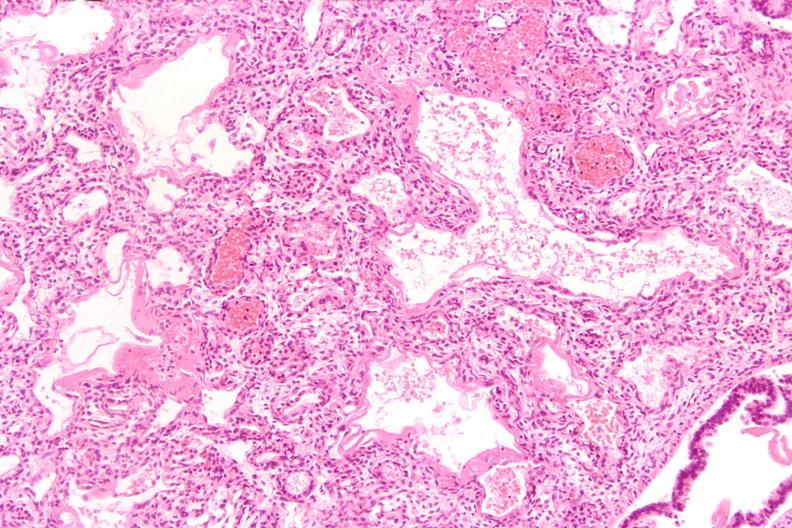does ulcer due to tube show lungs, hyaline membrane disease?
Answer the question using a single word or phrase. No 